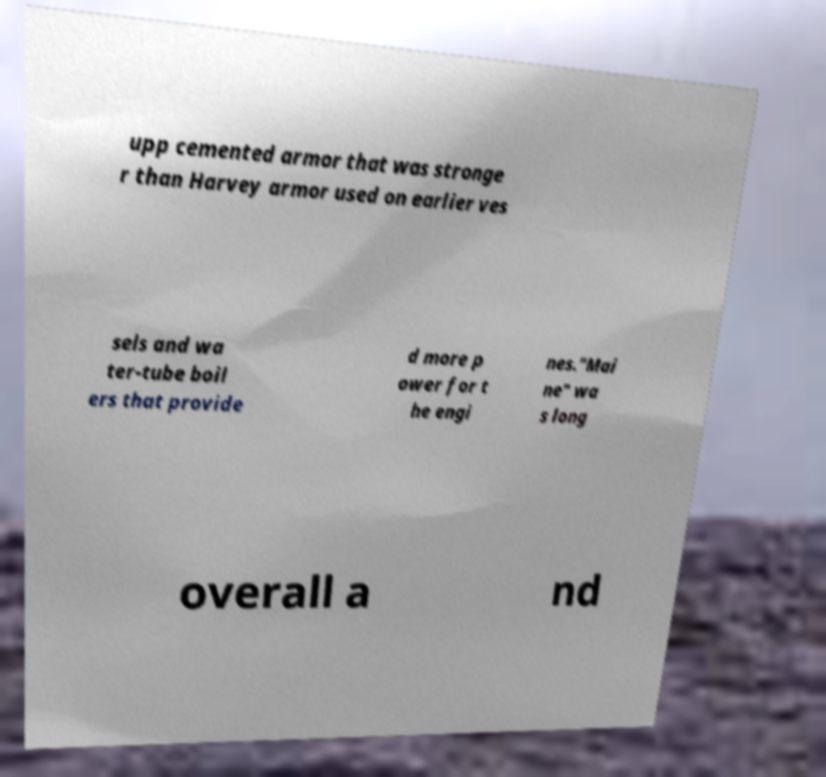For documentation purposes, I need the text within this image transcribed. Could you provide that? upp cemented armor that was stronge r than Harvey armor used on earlier ves sels and wa ter-tube boil ers that provide d more p ower for t he engi nes."Mai ne" wa s long overall a nd 